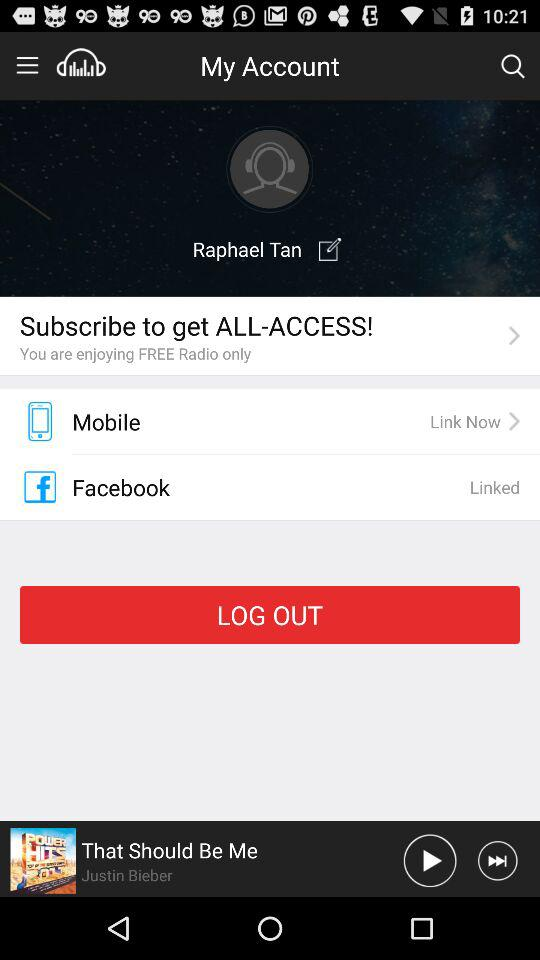Which song was last played? The last played song was "That Should Be Me". 